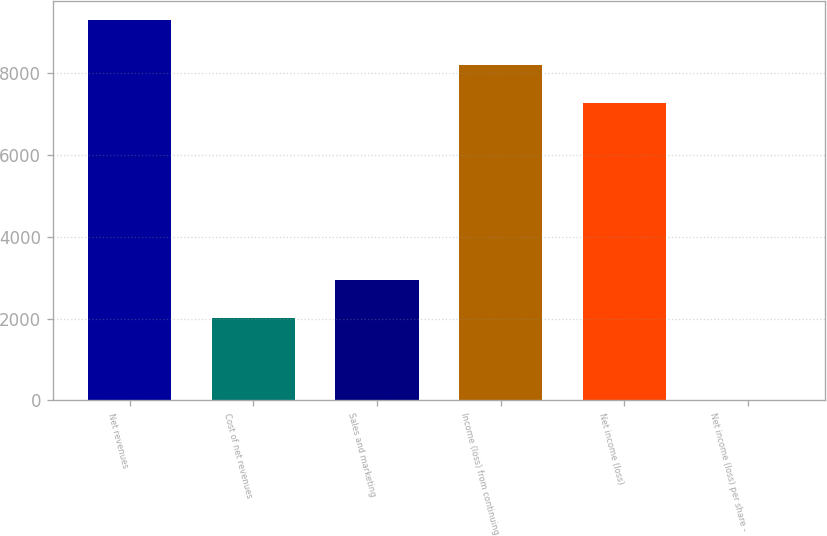Convert chart. <chart><loc_0><loc_0><loc_500><loc_500><bar_chart><fcel>Net revenues<fcel>Cost of net revenues<fcel>Sales and marketing<fcel>Income (loss) from continuing<fcel>Net income (loss)<fcel>Net income (loss) per share -<nl><fcel>9298<fcel>2005<fcel>2934.16<fcel>8195.17<fcel>7266<fcel>6.35<nl></chart> 